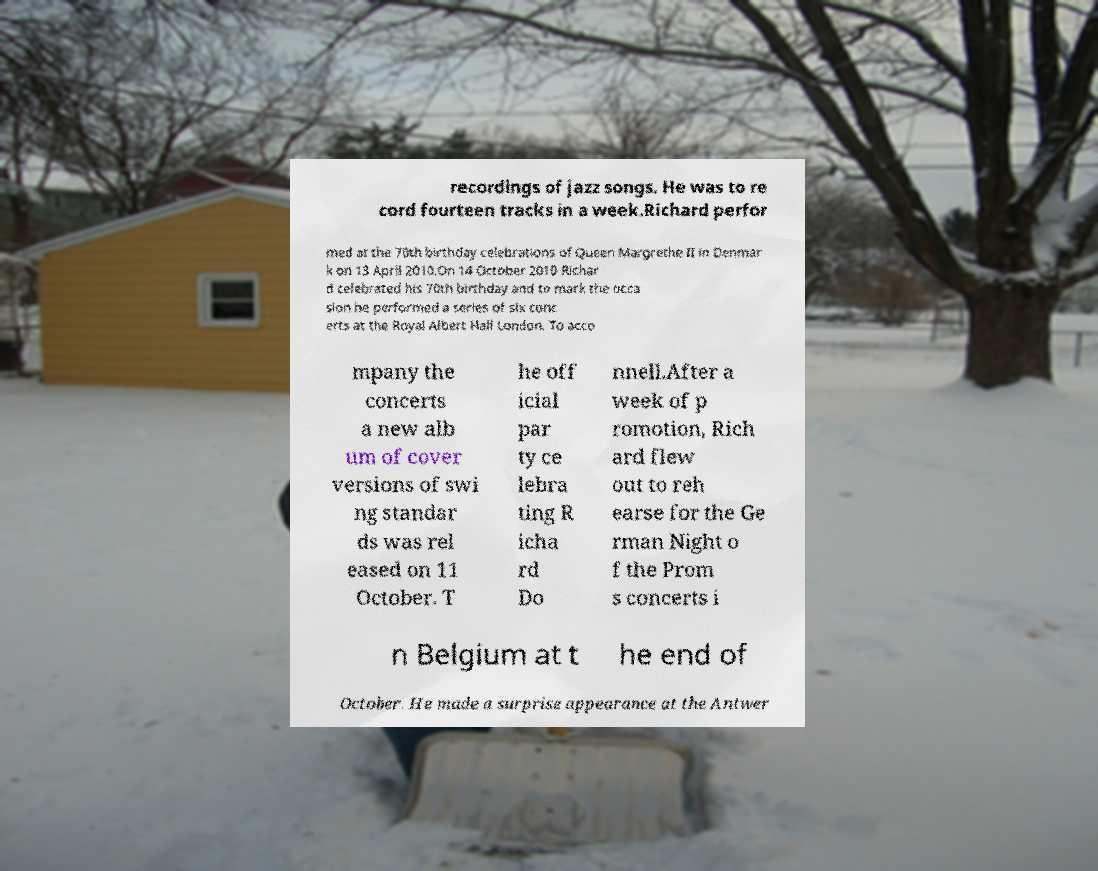Please identify and transcribe the text found in this image. recordings of jazz songs. He was to re cord fourteen tracks in a week.Richard perfor med at the 70th birthday celebrations of Queen Margrethe II in Denmar k on 13 April 2010.On 14 October 2010 Richar d celebrated his 70th birthday and to mark the occa sion he performed a series of six conc erts at the Royal Albert Hall London. To acco mpany the concerts a new alb um of cover versions of swi ng standar ds was rel eased on 11 October. T he off icial par ty ce lebra ting R icha rd Do nnell.After a week of p romotion, Rich ard flew out to reh earse for the Ge rman Night o f the Prom s concerts i n Belgium at t he end of October. He made a surprise appearance at the Antwer 